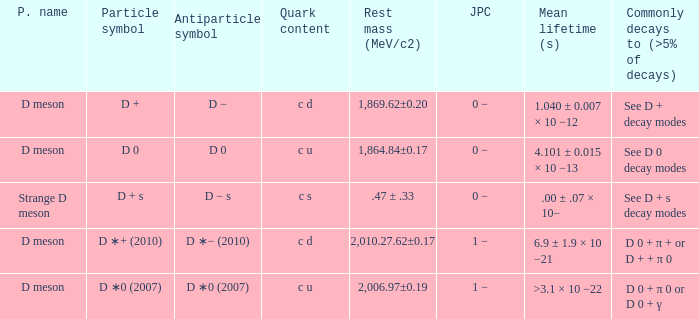What is the antiparticle symbol with a rest mess (mev/c2) of .47 ± .33? D − s. 